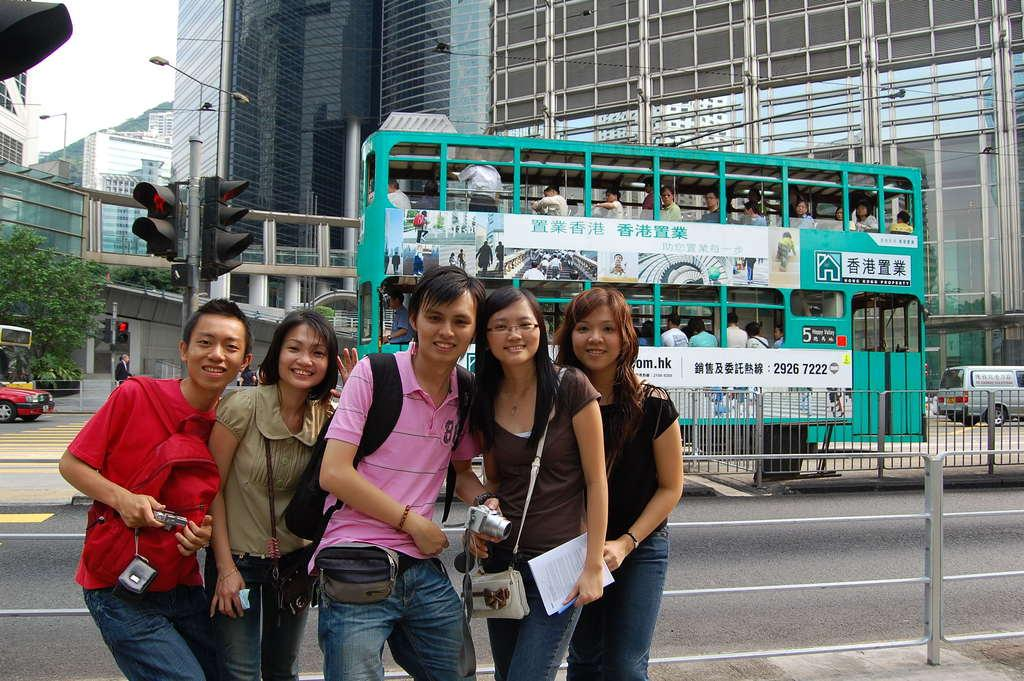<image>
Provide a brief description of the given image. Five people pose in front of a bus that advertises for a Hong Kong company with the phone number 2926 7222. 